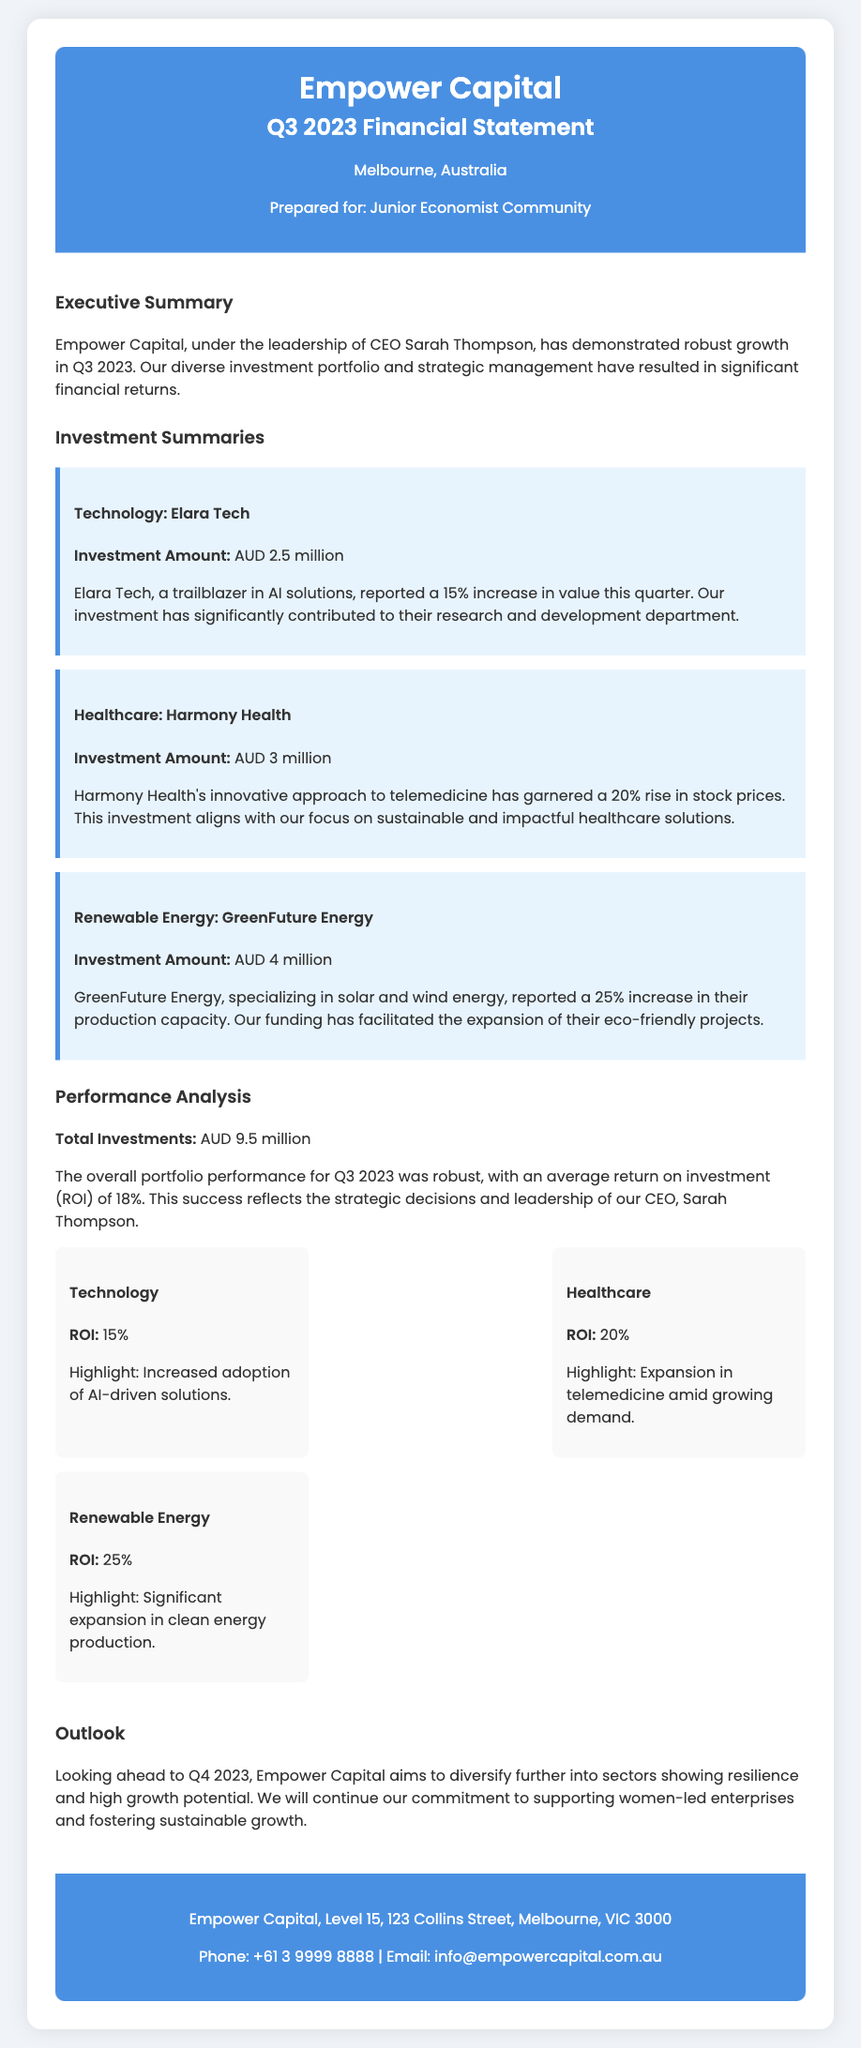What is the name of the CEO? The CEO's name is mentioned in the executive summary, highlighting her role in the company.
Answer: Sarah Thompson What was the total investment amount? The total investment amount is stated clearly in the performance analysis section.
Answer: AUD 9.5 million Which sector had the highest ROI? The performance analysis section provides specific ROI values for each sector, allowing us to compare them directly.
Answer: Renewable Energy What was the investment amount in Harmony Health? The investment amount is outlined in the investment summaries for each company.
Answer: AUD 3 million What percentage increase did GreenFuture Energy report? The document clearly states the percentage increase noted in the investment summary for GreenFuture Energy.
Answer: 25% What is the main focus of Empower Capital's outlook for Q4 2023? The outlook section indicates the specific areas of focus for future investments.
Answer: Diversify further What type of company is Elara Tech? The investment summary discusses what Elara Tech specializes in, defining its focus area.
Answer: AI solutions What was the ROI for the Technology sector? The performance section specifies the ROI for each mentioned sector, including Technology.
Answer: 15% What approach has Harmony Health taken? The investment summary describes Harmony Health's strategy, which illustrates its business model.
Answer: Telemedicine 